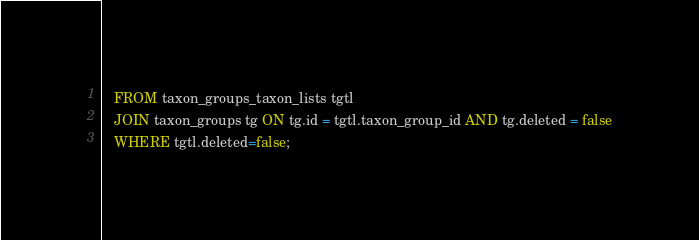Convert code to text. <code><loc_0><loc_0><loc_500><loc_500><_SQL_>   FROM taxon_groups_taxon_lists tgtl
   JOIN taxon_groups tg ON tg.id = tgtl.taxon_group_id AND tg.deleted = false
   WHERE tgtl.deleted=false;</code> 